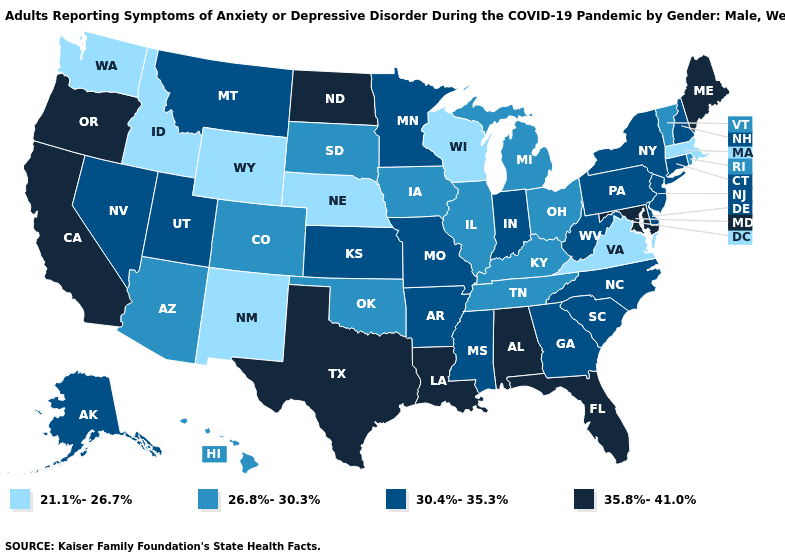Name the states that have a value in the range 26.8%-30.3%?
Answer briefly. Arizona, Colorado, Hawaii, Illinois, Iowa, Kentucky, Michigan, Ohio, Oklahoma, Rhode Island, South Dakota, Tennessee, Vermont. Among the states that border Georgia , which have the lowest value?
Keep it brief. Tennessee. What is the highest value in the South ?
Quick response, please. 35.8%-41.0%. Which states have the lowest value in the South?
Answer briefly. Virginia. Does Maryland have the same value as Delaware?
Quick response, please. No. What is the value of North Carolina?
Concise answer only. 30.4%-35.3%. What is the value of Kansas?
Give a very brief answer. 30.4%-35.3%. What is the value of Mississippi?
Concise answer only. 30.4%-35.3%. Name the states that have a value in the range 26.8%-30.3%?
Write a very short answer. Arizona, Colorado, Hawaii, Illinois, Iowa, Kentucky, Michigan, Ohio, Oklahoma, Rhode Island, South Dakota, Tennessee, Vermont. Name the states that have a value in the range 35.8%-41.0%?
Keep it brief. Alabama, California, Florida, Louisiana, Maine, Maryland, North Dakota, Oregon, Texas. Among the states that border North Dakota , does Minnesota have the lowest value?
Concise answer only. No. How many symbols are there in the legend?
Answer briefly. 4. What is the value of Rhode Island?
Give a very brief answer. 26.8%-30.3%. Which states have the lowest value in the USA?
Concise answer only. Idaho, Massachusetts, Nebraska, New Mexico, Virginia, Washington, Wisconsin, Wyoming. What is the value of Iowa?
Write a very short answer. 26.8%-30.3%. 